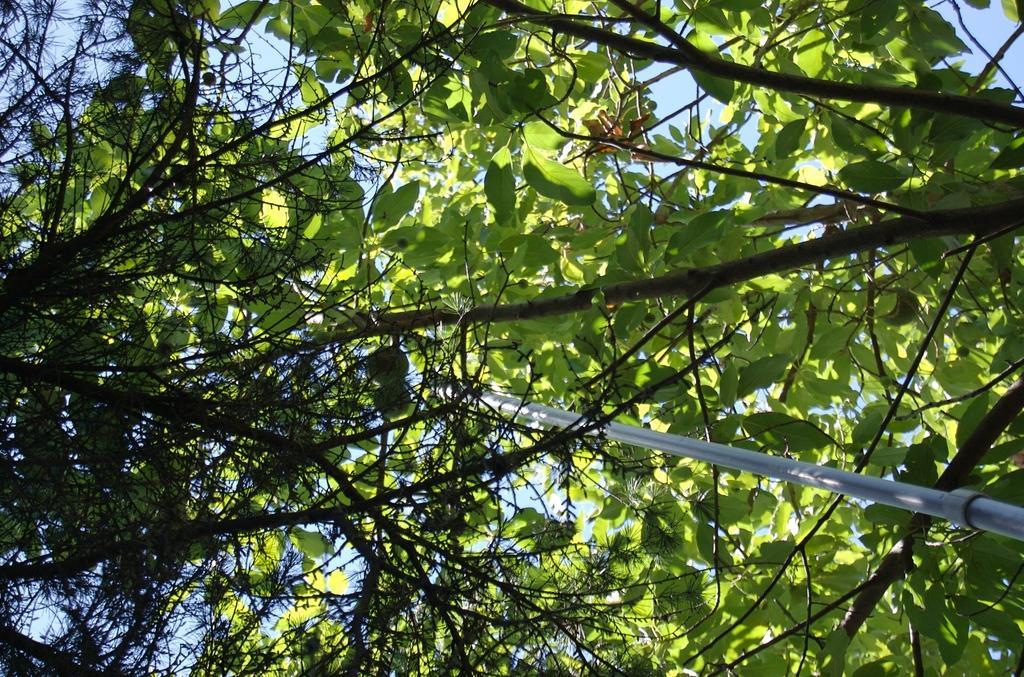In one or two sentences, can you explain what this image depicts? There are branches of a tree which has green leaves to it and there is a pole in between it. 